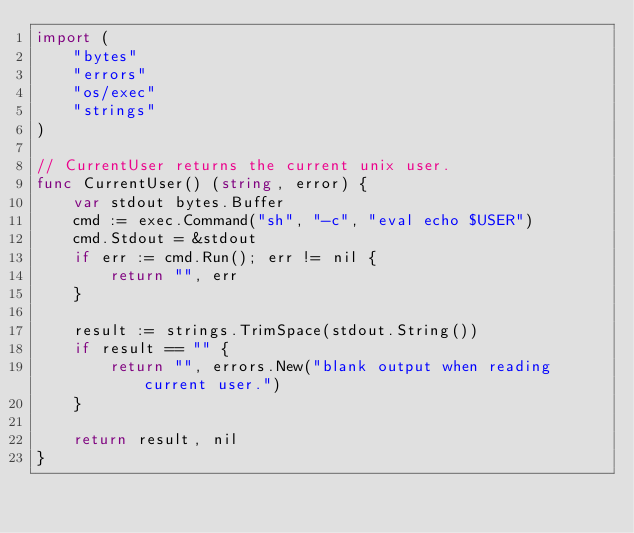Convert code to text. <code><loc_0><loc_0><loc_500><loc_500><_Go_>import (
	"bytes"
	"errors"
	"os/exec"
	"strings"
)

// CurrentUser returns the current unix user.
func CurrentUser() (string, error) {
	var stdout bytes.Buffer
	cmd := exec.Command("sh", "-c", "eval echo $USER")
	cmd.Stdout = &stdout
	if err := cmd.Run(); err != nil {
		return "", err
	}

	result := strings.TrimSpace(stdout.String())
	if result == "" {
		return "", errors.New("blank output when reading current user.")
	}

	return result, nil
}
</code> 